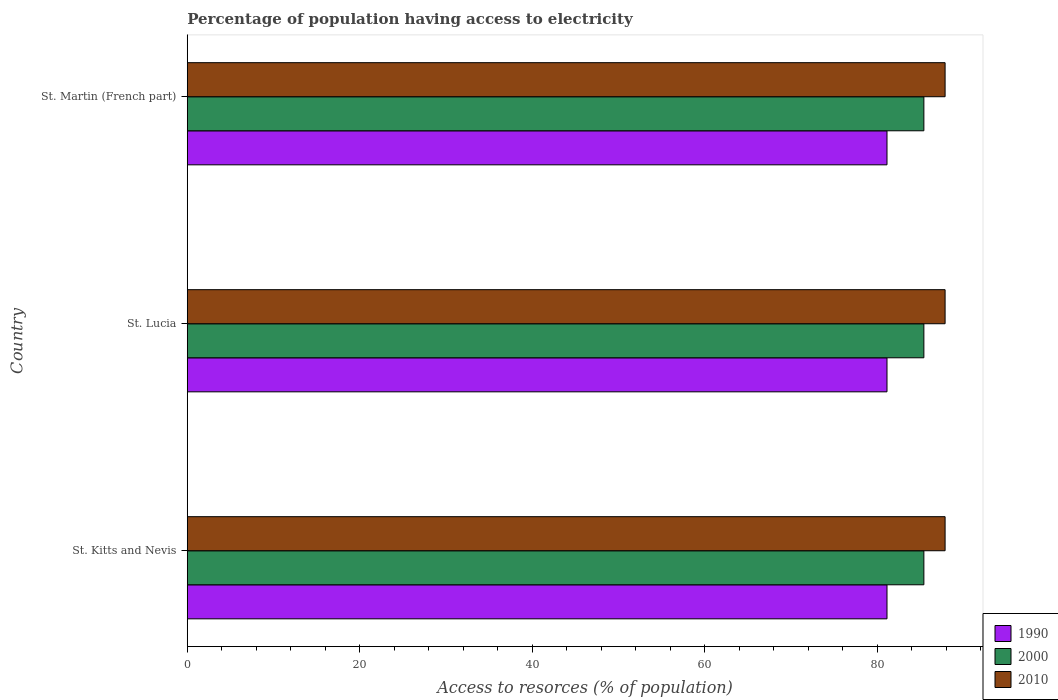How many different coloured bars are there?
Provide a succinct answer. 3. Are the number of bars per tick equal to the number of legend labels?
Make the answer very short. Yes. How many bars are there on the 2nd tick from the top?
Your response must be concise. 3. How many bars are there on the 1st tick from the bottom?
Give a very brief answer. 3. What is the label of the 3rd group of bars from the top?
Your answer should be very brief. St. Kitts and Nevis. In how many cases, is the number of bars for a given country not equal to the number of legend labels?
Offer a very short reply. 0. What is the percentage of population having access to electricity in 2010 in St. Martin (French part)?
Offer a terse response. 87.87. Across all countries, what is the maximum percentage of population having access to electricity in 2000?
Your answer should be very brief. 85.41. Across all countries, what is the minimum percentage of population having access to electricity in 2000?
Your answer should be compact. 85.41. In which country was the percentage of population having access to electricity in 1990 maximum?
Your answer should be compact. St. Kitts and Nevis. In which country was the percentage of population having access to electricity in 2010 minimum?
Offer a very short reply. St. Kitts and Nevis. What is the total percentage of population having access to electricity in 2010 in the graph?
Your answer should be compact. 263.62. What is the difference between the percentage of population having access to electricity in 2000 in St. Lucia and that in St. Martin (French part)?
Give a very brief answer. 0. What is the difference between the percentage of population having access to electricity in 2010 in St. Kitts and Nevis and the percentage of population having access to electricity in 2000 in St. Lucia?
Offer a very short reply. 2.46. What is the average percentage of population having access to electricity in 2000 per country?
Your response must be concise. 85.41. What is the difference between the percentage of population having access to electricity in 1990 and percentage of population having access to electricity in 2000 in St. Martin (French part)?
Offer a very short reply. -4.28. Is the percentage of population having access to electricity in 2000 in St. Lucia less than that in St. Martin (French part)?
Offer a very short reply. No. Is the difference between the percentage of population having access to electricity in 1990 in St. Lucia and St. Martin (French part) greater than the difference between the percentage of population having access to electricity in 2000 in St. Lucia and St. Martin (French part)?
Give a very brief answer. No. What is the difference between the highest and the second highest percentage of population having access to electricity in 2010?
Provide a succinct answer. 0. In how many countries, is the percentage of population having access to electricity in 1990 greater than the average percentage of population having access to electricity in 1990 taken over all countries?
Provide a short and direct response. 0. Is the sum of the percentage of population having access to electricity in 2010 in St. Kitts and Nevis and St. Martin (French part) greater than the maximum percentage of population having access to electricity in 2000 across all countries?
Offer a very short reply. Yes. What does the 3rd bar from the top in St. Lucia represents?
Your answer should be very brief. 1990. Is it the case that in every country, the sum of the percentage of population having access to electricity in 2000 and percentage of population having access to electricity in 2010 is greater than the percentage of population having access to electricity in 1990?
Offer a very short reply. Yes. How many bars are there?
Offer a very short reply. 9. Are all the bars in the graph horizontal?
Offer a very short reply. Yes. Are the values on the major ticks of X-axis written in scientific E-notation?
Your answer should be very brief. No. Does the graph contain any zero values?
Offer a terse response. No. Where does the legend appear in the graph?
Provide a succinct answer. Bottom right. What is the title of the graph?
Provide a succinct answer. Percentage of population having access to electricity. What is the label or title of the X-axis?
Offer a terse response. Access to resorces (% of population). What is the Access to resorces (% of population) in 1990 in St. Kitts and Nevis?
Your answer should be very brief. 81.14. What is the Access to resorces (% of population) in 2000 in St. Kitts and Nevis?
Offer a very short reply. 85.41. What is the Access to resorces (% of population) of 2010 in St. Kitts and Nevis?
Your answer should be compact. 87.87. What is the Access to resorces (% of population) in 1990 in St. Lucia?
Make the answer very short. 81.14. What is the Access to resorces (% of population) of 2000 in St. Lucia?
Offer a terse response. 85.41. What is the Access to resorces (% of population) of 2010 in St. Lucia?
Offer a terse response. 87.87. What is the Access to resorces (% of population) of 1990 in St. Martin (French part)?
Ensure brevity in your answer.  81.14. What is the Access to resorces (% of population) of 2000 in St. Martin (French part)?
Provide a succinct answer. 85.41. What is the Access to resorces (% of population) of 2010 in St. Martin (French part)?
Your response must be concise. 87.87. Across all countries, what is the maximum Access to resorces (% of population) of 1990?
Offer a very short reply. 81.14. Across all countries, what is the maximum Access to resorces (% of population) in 2000?
Make the answer very short. 85.41. Across all countries, what is the maximum Access to resorces (% of population) in 2010?
Ensure brevity in your answer.  87.87. Across all countries, what is the minimum Access to resorces (% of population) in 1990?
Offer a terse response. 81.14. Across all countries, what is the minimum Access to resorces (% of population) of 2000?
Ensure brevity in your answer.  85.41. Across all countries, what is the minimum Access to resorces (% of population) in 2010?
Offer a terse response. 87.87. What is the total Access to resorces (% of population) in 1990 in the graph?
Ensure brevity in your answer.  243.41. What is the total Access to resorces (% of population) of 2000 in the graph?
Provide a short and direct response. 256.23. What is the total Access to resorces (% of population) of 2010 in the graph?
Provide a succinct answer. 263.62. What is the difference between the Access to resorces (% of population) in 1990 in St. Kitts and Nevis and that in St. Lucia?
Provide a succinct answer. 0. What is the difference between the Access to resorces (% of population) in 2010 in St. Kitts and Nevis and that in St. Lucia?
Provide a succinct answer. 0. What is the difference between the Access to resorces (% of population) of 1990 in St. Kitts and Nevis and that in St. Martin (French part)?
Ensure brevity in your answer.  0. What is the difference between the Access to resorces (% of population) of 2010 in St. Kitts and Nevis and that in St. Martin (French part)?
Provide a succinct answer. 0. What is the difference between the Access to resorces (% of population) in 2000 in St. Lucia and that in St. Martin (French part)?
Ensure brevity in your answer.  0. What is the difference between the Access to resorces (% of population) of 2010 in St. Lucia and that in St. Martin (French part)?
Your answer should be very brief. 0. What is the difference between the Access to resorces (% of population) of 1990 in St. Kitts and Nevis and the Access to resorces (% of population) of 2000 in St. Lucia?
Provide a succinct answer. -4.28. What is the difference between the Access to resorces (% of population) in 1990 in St. Kitts and Nevis and the Access to resorces (% of population) in 2010 in St. Lucia?
Offer a terse response. -6.74. What is the difference between the Access to resorces (% of population) in 2000 in St. Kitts and Nevis and the Access to resorces (% of population) in 2010 in St. Lucia?
Your answer should be compact. -2.46. What is the difference between the Access to resorces (% of population) of 1990 in St. Kitts and Nevis and the Access to resorces (% of population) of 2000 in St. Martin (French part)?
Offer a very short reply. -4.28. What is the difference between the Access to resorces (% of population) in 1990 in St. Kitts and Nevis and the Access to resorces (% of population) in 2010 in St. Martin (French part)?
Your response must be concise. -6.74. What is the difference between the Access to resorces (% of population) in 2000 in St. Kitts and Nevis and the Access to resorces (% of population) in 2010 in St. Martin (French part)?
Offer a very short reply. -2.46. What is the difference between the Access to resorces (% of population) of 1990 in St. Lucia and the Access to resorces (% of population) of 2000 in St. Martin (French part)?
Your answer should be compact. -4.28. What is the difference between the Access to resorces (% of population) of 1990 in St. Lucia and the Access to resorces (% of population) of 2010 in St. Martin (French part)?
Ensure brevity in your answer.  -6.74. What is the difference between the Access to resorces (% of population) of 2000 in St. Lucia and the Access to resorces (% of population) of 2010 in St. Martin (French part)?
Offer a very short reply. -2.46. What is the average Access to resorces (% of population) of 1990 per country?
Give a very brief answer. 81.14. What is the average Access to resorces (% of population) in 2000 per country?
Offer a terse response. 85.41. What is the average Access to resorces (% of population) of 2010 per country?
Your response must be concise. 87.87. What is the difference between the Access to resorces (% of population) in 1990 and Access to resorces (% of population) in 2000 in St. Kitts and Nevis?
Provide a short and direct response. -4.28. What is the difference between the Access to resorces (% of population) in 1990 and Access to resorces (% of population) in 2010 in St. Kitts and Nevis?
Offer a terse response. -6.74. What is the difference between the Access to resorces (% of population) in 2000 and Access to resorces (% of population) in 2010 in St. Kitts and Nevis?
Provide a succinct answer. -2.46. What is the difference between the Access to resorces (% of population) of 1990 and Access to resorces (% of population) of 2000 in St. Lucia?
Ensure brevity in your answer.  -4.28. What is the difference between the Access to resorces (% of population) of 1990 and Access to resorces (% of population) of 2010 in St. Lucia?
Keep it short and to the point. -6.74. What is the difference between the Access to resorces (% of population) of 2000 and Access to resorces (% of population) of 2010 in St. Lucia?
Make the answer very short. -2.46. What is the difference between the Access to resorces (% of population) in 1990 and Access to resorces (% of population) in 2000 in St. Martin (French part)?
Provide a short and direct response. -4.28. What is the difference between the Access to resorces (% of population) of 1990 and Access to resorces (% of population) of 2010 in St. Martin (French part)?
Your answer should be very brief. -6.74. What is the difference between the Access to resorces (% of population) in 2000 and Access to resorces (% of population) in 2010 in St. Martin (French part)?
Offer a very short reply. -2.46. What is the ratio of the Access to resorces (% of population) in 1990 in St. Kitts and Nevis to that in St. Lucia?
Give a very brief answer. 1. What is the ratio of the Access to resorces (% of population) in 2000 in St. Kitts and Nevis to that in St. Lucia?
Offer a very short reply. 1. What is the ratio of the Access to resorces (% of population) of 2000 in St. Kitts and Nevis to that in St. Martin (French part)?
Your response must be concise. 1. What is the ratio of the Access to resorces (% of population) of 2010 in St. Kitts and Nevis to that in St. Martin (French part)?
Provide a succinct answer. 1. What is the ratio of the Access to resorces (% of population) of 2000 in St. Lucia to that in St. Martin (French part)?
Your response must be concise. 1. What is the ratio of the Access to resorces (% of population) of 2010 in St. Lucia to that in St. Martin (French part)?
Give a very brief answer. 1. What is the difference between the highest and the second highest Access to resorces (% of population) of 1990?
Offer a very short reply. 0. What is the difference between the highest and the lowest Access to resorces (% of population) of 1990?
Your response must be concise. 0. 